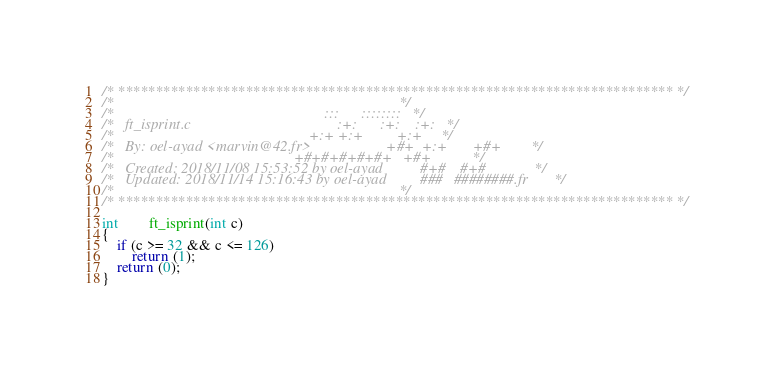Convert code to text. <code><loc_0><loc_0><loc_500><loc_500><_C_>/* ************************************************************************** */
/*                                                                            */
/*                                                        :::      ::::::::   */
/*   ft_isprint.c                                       :+:      :+:    :+:   */
/*                                                    +:+ +:+         +:+     */
/*   By: oel-ayad <marvin@42.fr>                    +#+  +:+       +#+        */
/*                                                +#+#+#+#+#+   +#+           */
/*   Created: 2018/11/08 15:53:52 by oel-ayad          #+#    #+#             */
/*   Updated: 2018/11/14 15:16:43 by oel-ayad         ###   ########.fr       */
/*                                                                            */
/* ************************************************************************** */

int		ft_isprint(int c)
{
	if (c >= 32 && c <= 126)
		return (1);
	return (0);
}
</code> 